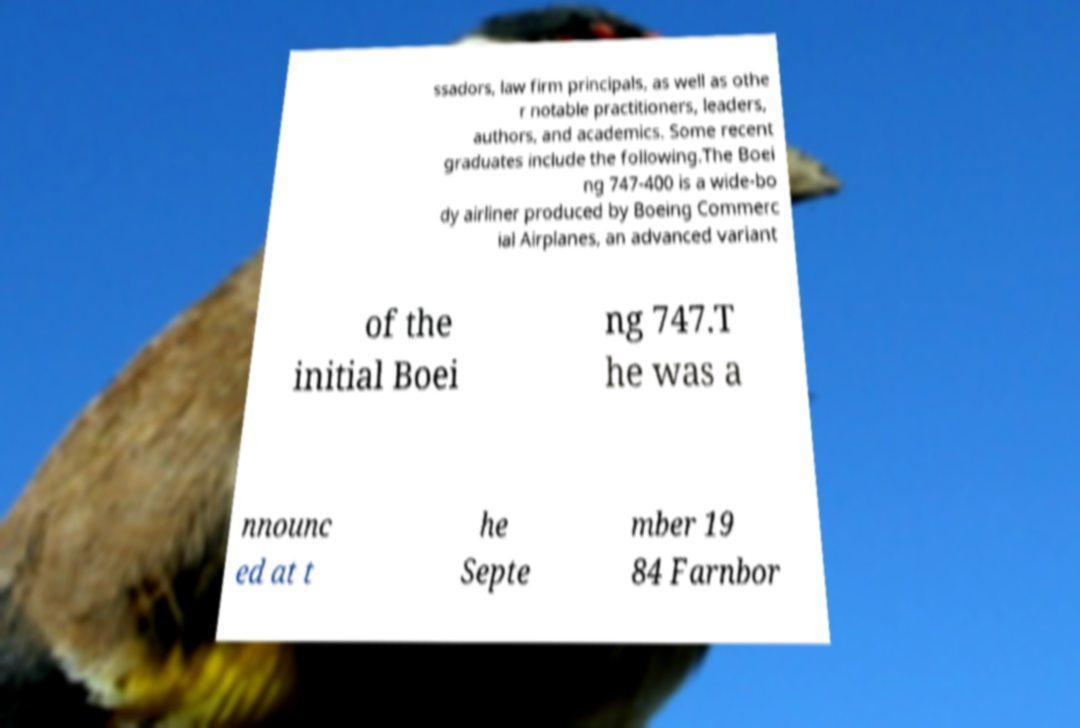There's text embedded in this image that I need extracted. Can you transcribe it verbatim? ssadors, law firm principals, as well as othe r notable practitioners, leaders, authors, and academics. Some recent graduates include the following.The Boei ng 747-400 is a wide-bo dy airliner produced by Boeing Commerc ial Airplanes, an advanced variant of the initial Boei ng 747.T he was a nnounc ed at t he Septe mber 19 84 Farnbor 